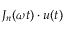<formula> <loc_0><loc_0><loc_500><loc_500>J _ { n } ( \omega t ) \cdot u ( t )</formula> 